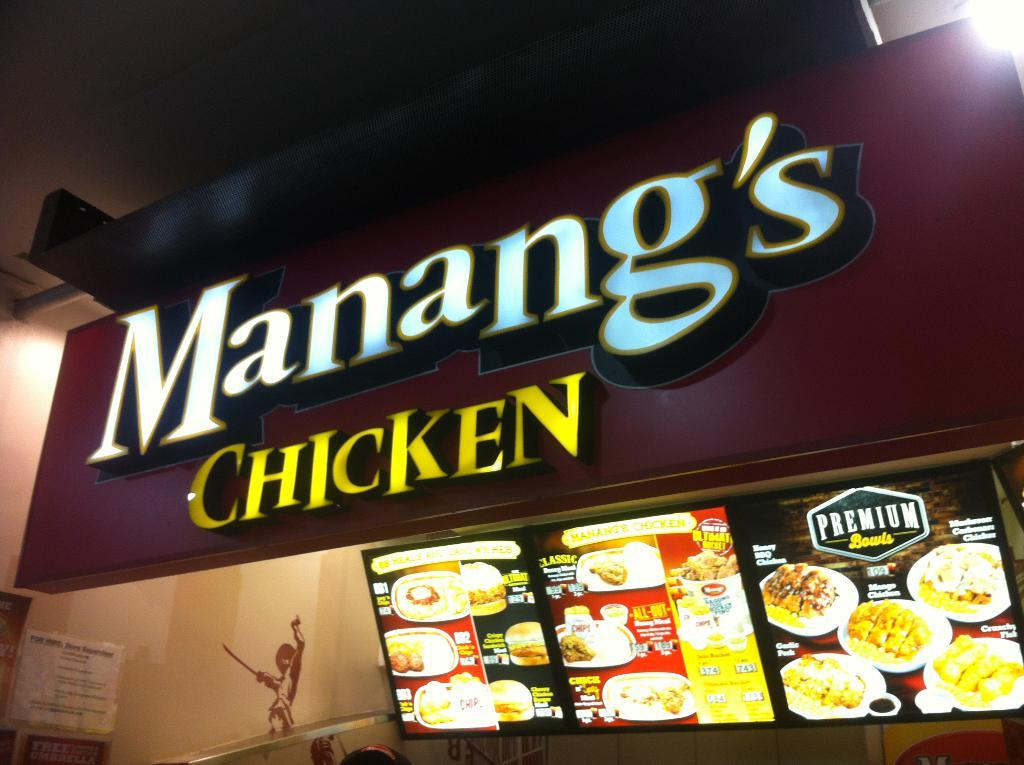What is the main object in the image? There is a light board in the image. What can be seen on the screens in the image? The screens display food items and prices in the image. What is attached to the wall in the image? There are papers stuck to the wall in the image. Where is the hydrant located in the image? There is no hydrant present in the image. What type of throne is depicted on the light board? There is no throne present in the image; the light board displays food items and prices. 